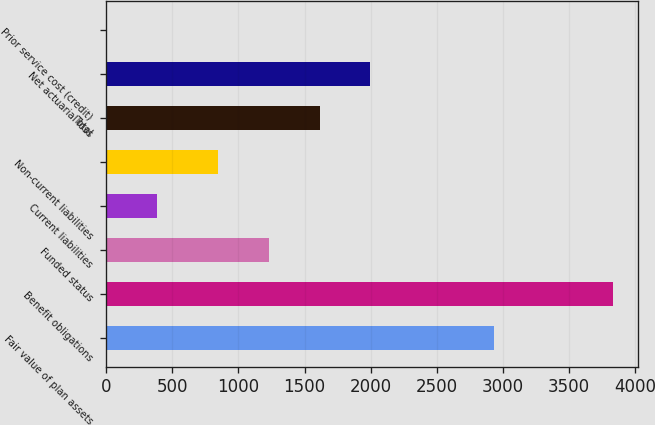Convert chart. <chart><loc_0><loc_0><loc_500><loc_500><bar_chart><fcel>Fair value of plan assets<fcel>Benefit obligations<fcel>Funded status<fcel>Current liabilities<fcel>Non-current liabilities<fcel>Total<fcel>Net actuarial loss<fcel>Prior service cost (credit)<nl><fcel>2934<fcel>3829<fcel>1231.4<fcel>387.4<fcel>849<fcel>1613.8<fcel>1996.2<fcel>5<nl></chart> 